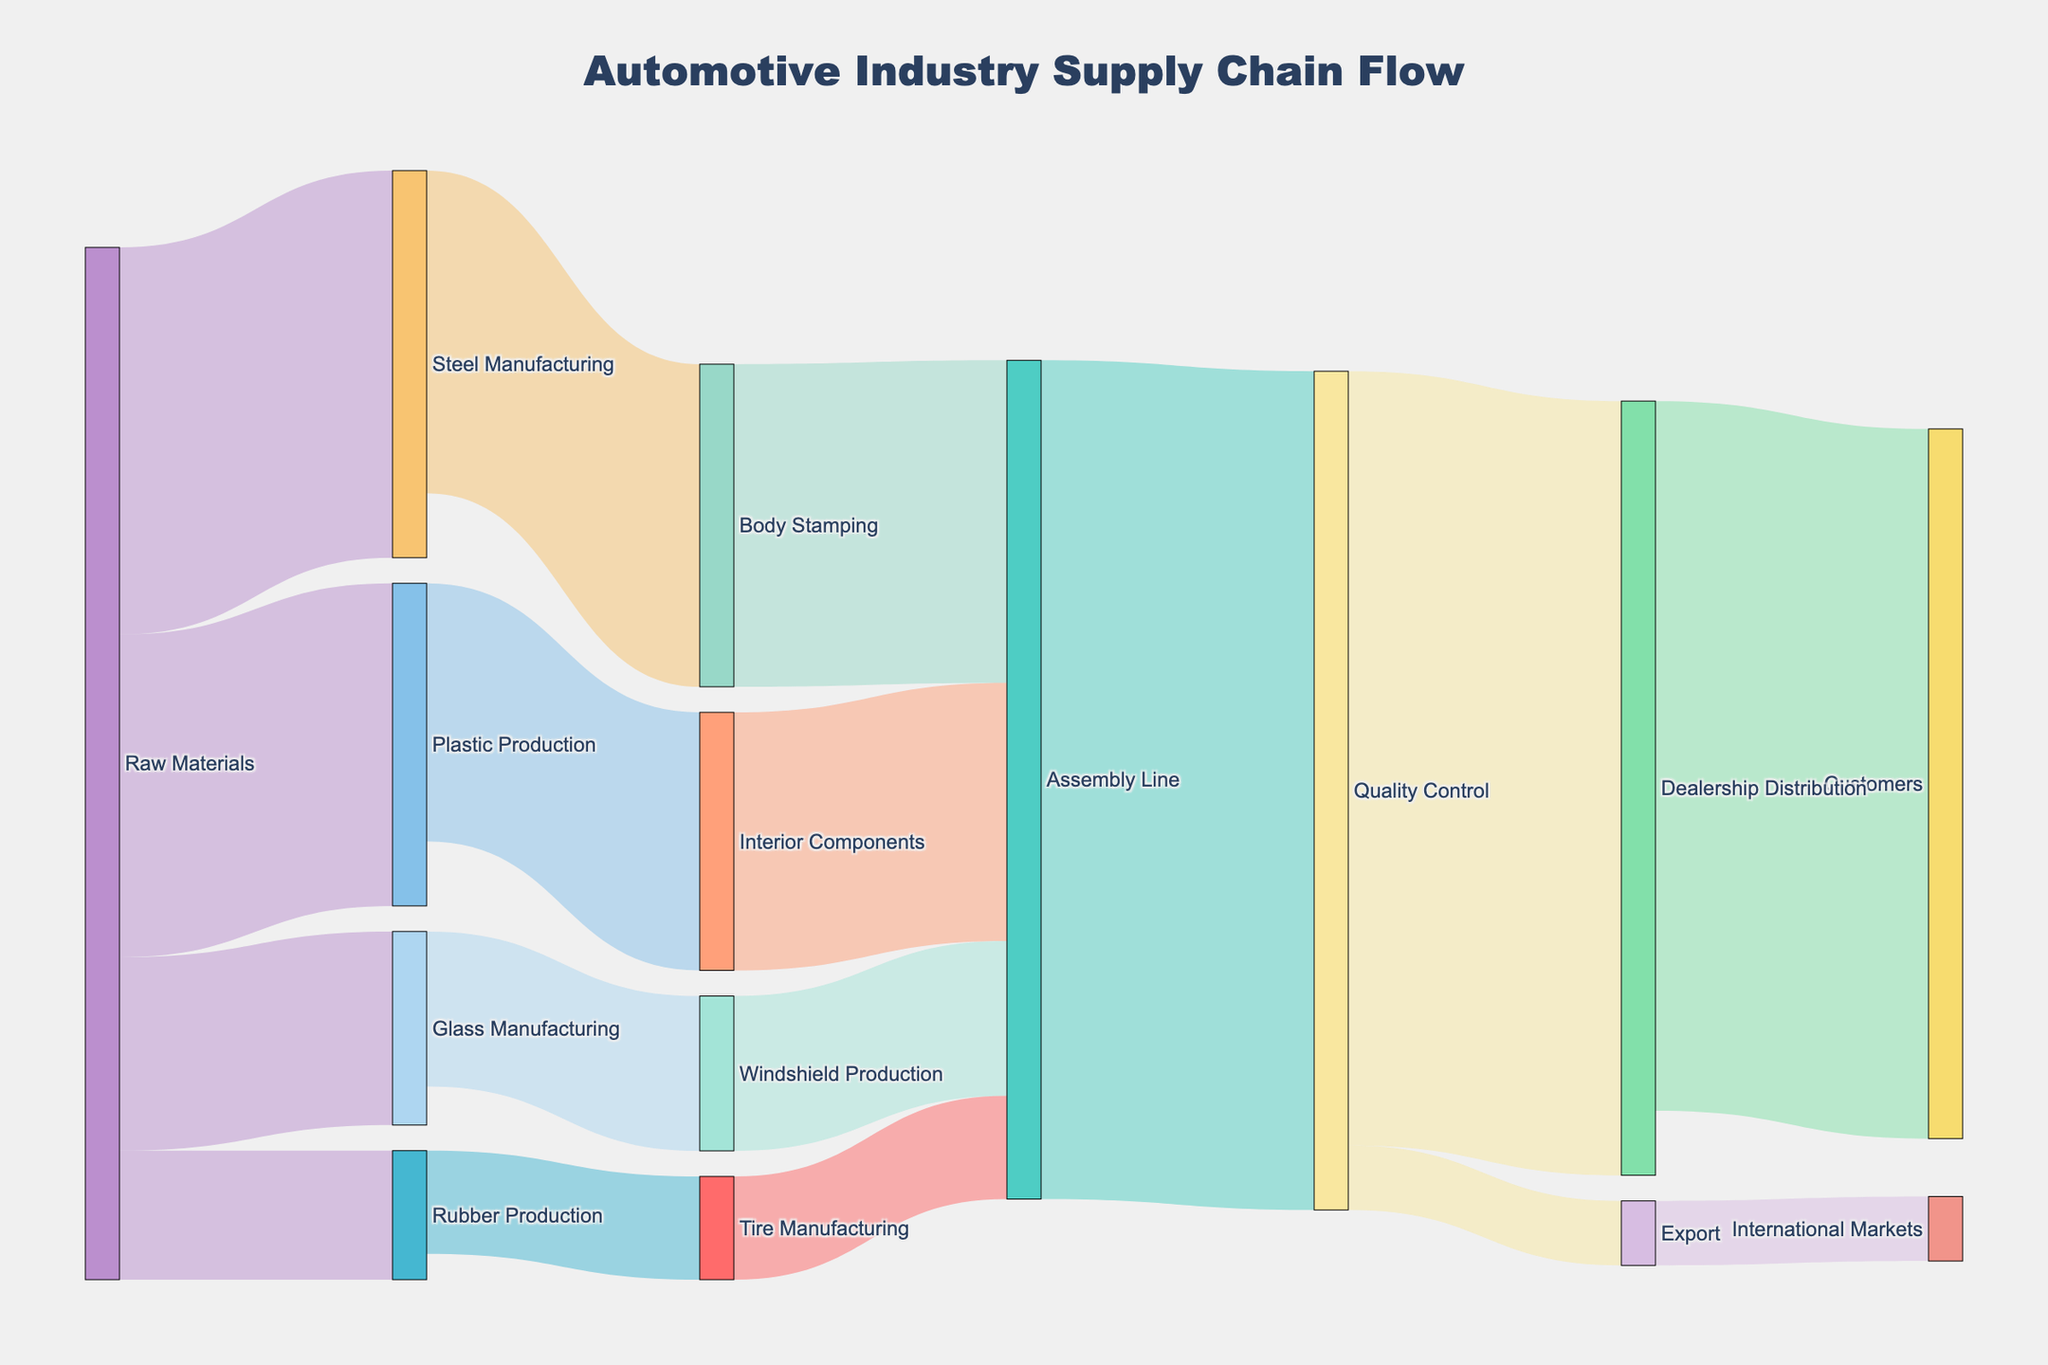What is the title of the Sankey Diagram? The title is located at the top center of the figure. It is meant to give a brief summary of the content being visualized.
Answer: Automotive Industry Supply Chain Flow Which step receives the highest amount of raw materials flows? By observing the nodes (rectangles) and the links (arrows), you can see the highest value in the first step.
Answer: Steel Manufacturing How much of the product from Quality Control goes to Dealership Distribution? Follow the links coming out of Quality Control. Identify the link leading to Dealership Distribution and note its value.
Answer: 60 Which steps are involved in the Assembly Line? Trace the nodes and connections leading to and from the Assembly Line. The connected steps are linked visually by arrows.
Answer: Body Stamping, Interior Components, Windshield Production, Tire Manufacturing, Quality Control What is the combined value of products exported to International Markets from Quality Control and Dealership Distribution? Follow the links from both Quality Control and Dealership Distribution nodes to their respective targets. Sum the values of these links.
Answer: 5 Which production step has the least flow from raw materials? Check the links originating from Raw Materials and identify the one with the smallest value.
Answer: Rubber Production How does the value flowing into Customers compare to the value flowing into International Markets? Examine the nodes for Customers and International Markets and compare the values represented by the links flowing into them.
Answer: Customers receives more What percentage of the final products going through the Quality Control are distributed to dealerships? Calculate the ratio of the value going to Dealership Distribution over the total value from Quality Control and multiply by 100.
Answer: 92.3% How many unique steps are involved in the entire automotive supply chain, from raw materials to final distribution? Count the total unique nodes in the diagram that represent different steps.
Answer: 12 Which two steps have a direct connection with each other and also connect back to a common downstream node? Look for pairs of nodes that are both connected to another single node downstream, forming a three-node chain.
Answer: Body Stamping and Quality Control both connect with Assembly Line 